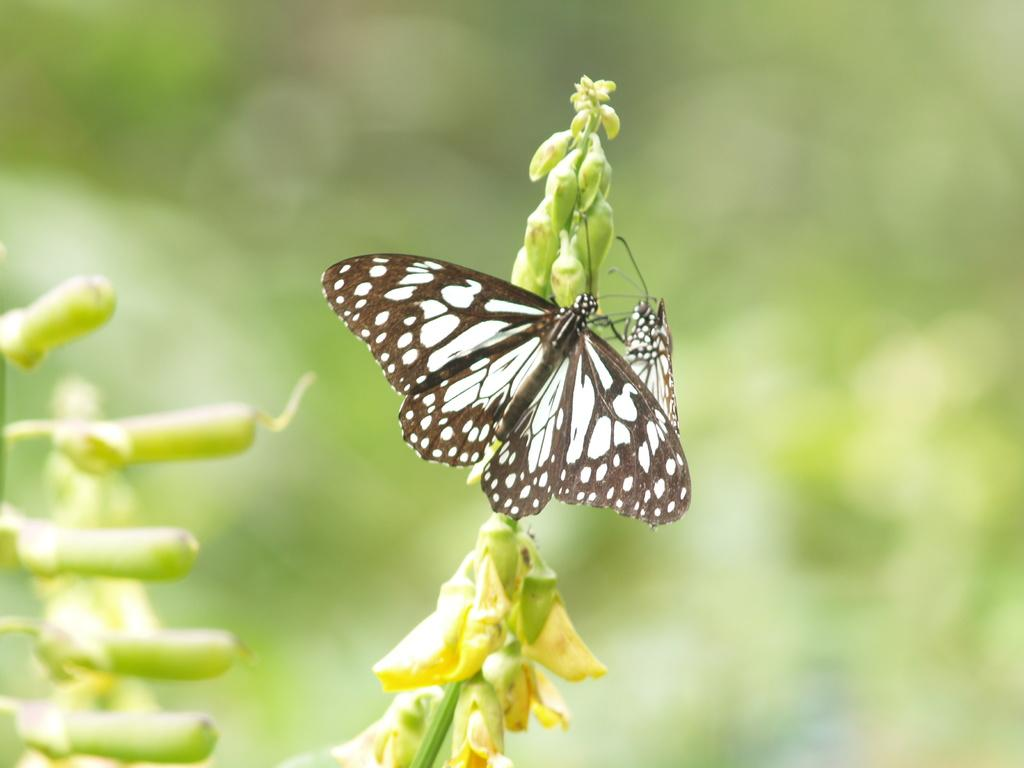What is the main subject in the center of the image? There is a plant in the center of the image. What is on the plant? There are two butterflies on the plant. What color are the butterflies? The butterflies are in black and white color. What type of statement does the horse make in the image? There is no horse present in the image, so it cannot make any statements. 